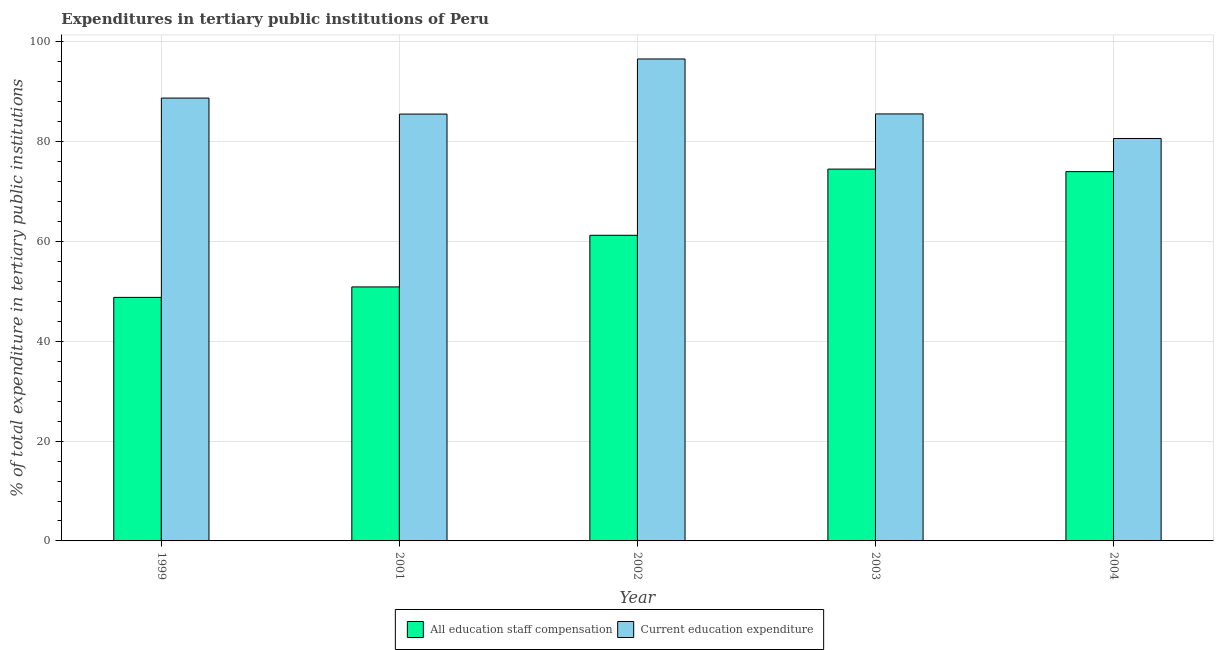How many different coloured bars are there?
Your answer should be compact. 2. Are the number of bars on each tick of the X-axis equal?
Offer a terse response. Yes. How many bars are there on the 1st tick from the left?
Your answer should be very brief. 2. What is the expenditure in education in 2001?
Offer a very short reply. 85.55. Across all years, what is the maximum expenditure in education?
Ensure brevity in your answer.  96.6. Across all years, what is the minimum expenditure in education?
Provide a succinct answer. 80.66. In which year was the expenditure in staff compensation maximum?
Ensure brevity in your answer.  2003. In which year was the expenditure in staff compensation minimum?
Keep it short and to the point. 1999. What is the total expenditure in education in the graph?
Provide a succinct answer. 437.14. What is the difference between the expenditure in education in 1999 and that in 2001?
Make the answer very short. 3.21. What is the difference between the expenditure in staff compensation in 2003 and the expenditure in education in 2004?
Ensure brevity in your answer.  0.51. What is the average expenditure in staff compensation per year?
Make the answer very short. 61.9. What is the ratio of the expenditure in education in 1999 to that in 2001?
Give a very brief answer. 1.04. Is the expenditure in education in 2001 less than that in 2004?
Give a very brief answer. No. Is the difference between the expenditure in education in 1999 and 2002 greater than the difference between the expenditure in staff compensation in 1999 and 2002?
Keep it short and to the point. No. What is the difference between the highest and the second highest expenditure in education?
Keep it short and to the point. 7.84. What is the difference between the highest and the lowest expenditure in education?
Give a very brief answer. 15.93. In how many years, is the expenditure in staff compensation greater than the average expenditure in staff compensation taken over all years?
Offer a very short reply. 2. Is the sum of the expenditure in education in 1999 and 2001 greater than the maximum expenditure in staff compensation across all years?
Your response must be concise. Yes. What does the 2nd bar from the left in 2003 represents?
Give a very brief answer. Current education expenditure. What does the 2nd bar from the right in 2001 represents?
Your response must be concise. All education staff compensation. How many bars are there?
Ensure brevity in your answer.  10. Are the values on the major ticks of Y-axis written in scientific E-notation?
Provide a short and direct response. No. Does the graph contain grids?
Provide a succinct answer. Yes. How are the legend labels stacked?
Keep it short and to the point. Horizontal. What is the title of the graph?
Your answer should be very brief. Expenditures in tertiary public institutions of Peru. Does "Male population" appear as one of the legend labels in the graph?
Your answer should be compact. No. What is the label or title of the Y-axis?
Offer a terse response. % of total expenditure in tertiary public institutions. What is the % of total expenditure in tertiary public institutions of All education staff compensation in 1999?
Keep it short and to the point. 48.81. What is the % of total expenditure in tertiary public institutions of Current education expenditure in 1999?
Give a very brief answer. 88.76. What is the % of total expenditure in tertiary public institutions of All education staff compensation in 2001?
Provide a succinct answer. 50.91. What is the % of total expenditure in tertiary public institutions of Current education expenditure in 2001?
Your answer should be very brief. 85.55. What is the % of total expenditure in tertiary public institutions in All education staff compensation in 2002?
Offer a terse response. 61.26. What is the % of total expenditure in tertiary public institutions of Current education expenditure in 2002?
Offer a terse response. 96.6. What is the % of total expenditure in tertiary public institutions of All education staff compensation in 2003?
Make the answer very short. 74.52. What is the % of total expenditure in tertiary public institutions in Current education expenditure in 2003?
Offer a very short reply. 85.58. What is the % of total expenditure in tertiary public institutions of All education staff compensation in 2004?
Your answer should be very brief. 74.02. What is the % of total expenditure in tertiary public institutions of Current education expenditure in 2004?
Ensure brevity in your answer.  80.66. Across all years, what is the maximum % of total expenditure in tertiary public institutions in All education staff compensation?
Provide a short and direct response. 74.52. Across all years, what is the maximum % of total expenditure in tertiary public institutions of Current education expenditure?
Keep it short and to the point. 96.6. Across all years, what is the minimum % of total expenditure in tertiary public institutions of All education staff compensation?
Your answer should be very brief. 48.81. Across all years, what is the minimum % of total expenditure in tertiary public institutions in Current education expenditure?
Ensure brevity in your answer.  80.66. What is the total % of total expenditure in tertiary public institutions of All education staff compensation in the graph?
Give a very brief answer. 309.52. What is the total % of total expenditure in tertiary public institutions of Current education expenditure in the graph?
Your answer should be very brief. 437.14. What is the difference between the % of total expenditure in tertiary public institutions in All education staff compensation in 1999 and that in 2001?
Your answer should be compact. -2.1. What is the difference between the % of total expenditure in tertiary public institutions in Current education expenditure in 1999 and that in 2001?
Offer a very short reply. 3.21. What is the difference between the % of total expenditure in tertiary public institutions of All education staff compensation in 1999 and that in 2002?
Provide a short and direct response. -12.44. What is the difference between the % of total expenditure in tertiary public institutions of Current education expenditure in 1999 and that in 2002?
Your answer should be compact. -7.84. What is the difference between the % of total expenditure in tertiary public institutions of All education staff compensation in 1999 and that in 2003?
Offer a very short reply. -25.71. What is the difference between the % of total expenditure in tertiary public institutions of Current education expenditure in 1999 and that in 2003?
Your answer should be very brief. 3.18. What is the difference between the % of total expenditure in tertiary public institutions of All education staff compensation in 1999 and that in 2004?
Offer a very short reply. -25.2. What is the difference between the % of total expenditure in tertiary public institutions in Current education expenditure in 1999 and that in 2004?
Give a very brief answer. 8.09. What is the difference between the % of total expenditure in tertiary public institutions in All education staff compensation in 2001 and that in 2002?
Your answer should be compact. -10.34. What is the difference between the % of total expenditure in tertiary public institutions in Current education expenditure in 2001 and that in 2002?
Offer a very short reply. -11.05. What is the difference between the % of total expenditure in tertiary public institutions of All education staff compensation in 2001 and that in 2003?
Provide a short and direct response. -23.61. What is the difference between the % of total expenditure in tertiary public institutions in Current education expenditure in 2001 and that in 2003?
Offer a very short reply. -0.03. What is the difference between the % of total expenditure in tertiary public institutions of All education staff compensation in 2001 and that in 2004?
Provide a short and direct response. -23.1. What is the difference between the % of total expenditure in tertiary public institutions in Current education expenditure in 2001 and that in 2004?
Your answer should be compact. 4.89. What is the difference between the % of total expenditure in tertiary public institutions of All education staff compensation in 2002 and that in 2003?
Your answer should be compact. -13.27. What is the difference between the % of total expenditure in tertiary public institutions in Current education expenditure in 2002 and that in 2003?
Keep it short and to the point. 11.02. What is the difference between the % of total expenditure in tertiary public institutions of All education staff compensation in 2002 and that in 2004?
Ensure brevity in your answer.  -12.76. What is the difference between the % of total expenditure in tertiary public institutions of Current education expenditure in 2002 and that in 2004?
Keep it short and to the point. 15.93. What is the difference between the % of total expenditure in tertiary public institutions in All education staff compensation in 2003 and that in 2004?
Keep it short and to the point. 0.51. What is the difference between the % of total expenditure in tertiary public institutions in Current education expenditure in 2003 and that in 2004?
Provide a succinct answer. 4.92. What is the difference between the % of total expenditure in tertiary public institutions in All education staff compensation in 1999 and the % of total expenditure in tertiary public institutions in Current education expenditure in 2001?
Make the answer very short. -36.74. What is the difference between the % of total expenditure in tertiary public institutions in All education staff compensation in 1999 and the % of total expenditure in tertiary public institutions in Current education expenditure in 2002?
Keep it short and to the point. -47.78. What is the difference between the % of total expenditure in tertiary public institutions of All education staff compensation in 1999 and the % of total expenditure in tertiary public institutions of Current education expenditure in 2003?
Give a very brief answer. -36.77. What is the difference between the % of total expenditure in tertiary public institutions of All education staff compensation in 1999 and the % of total expenditure in tertiary public institutions of Current education expenditure in 2004?
Provide a short and direct response. -31.85. What is the difference between the % of total expenditure in tertiary public institutions of All education staff compensation in 2001 and the % of total expenditure in tertiary public institutions of Current education expenditure in 2002?
Provide a short and direct response. -45.68. What is the difference between the % of total expenditure in tertiary public institutions in All education staff compensation in 2001 and the % of total expenditure in tertiary public institutions in Current education expenditure in 2003?
Offer a very short reply. -34.67. What is the difference between the % of total expenditure in tertiary public institutions of All education staff compensation in 2001 and the % of total expenditure in tertiary public institutions of Current education expenditure in 2004?
Make the answer very short. -29.75. What is the difference between the % of total expenditure in tertiary public institutions in All education staff compensation in 2002 and the % of total expenditure in tertiary public institutions in Current education expenditure in 2003?
Your answer should be very brief. -24.32. What is the difference between the % of total expenditure in tertiary public institutions of All education staff compensation in 2002 and the % of total expenditure in tertiary public institutions of Current education expenditure in 2004?
Offer a very short reply. -19.41. What is the difference between the % of total expenditure in tertiary public institutions of All education staff compensation in 2003 and the % of total expenditure in tertiary public institutions of Current education expenditure in 2004?
Keep it short and to the point. -6.14. What is the average % of total expenditure in tertiary public institutions of All education staff compensation per year?
Your response must be concise. 61.9. What is the average % of total expenditure in tertiary public institutions in Current education expenditure per year?
Offer a very short reply. 87.43. In the year 1999, what is the difference between the % of total expenditure in tertiary public institutions of All education staff compensation and % of total expenditure in tertiary public institutions of Current education expenditure?
Offer a very short reply. -39.94. In the year 2001, what is the difference between the % of total expenditure in tertiary public institutions in All education staff compensation and % of total expenditure in tertiary public institutions in Current education expenditure?
Ensure brevity in your answer.  -34.64. In the year 2002, what is the difference between the % of total expenditure in tertiary public institutions in All education staff compensation and % of total expenditure in tertiary public institutions in Current education expenditure?
Provide a succinct answer. -35.34. In the year 2003, what is the difference between the % of total expenditure in tertiary public institutions of All education staff compensation and % of total expenditure in tertiary public institutions of Current education expenditure?
Provide a succinct answer. -11.06. In the year 2004, what is the difference between the % of total expenditure in tertiary public institutions in All education staff compensation and % of total expenditure in tertiary public institutions in Current education expenditure?
Your answer should be compact. -6.65. What is the ratio of the % of total expenditure in tertiary public institutions in All education staff compensation in 1999 to that in 2001?
Ensure brevity in your answer.  0.96. What is the ratio of the % of total expenditure in tertiary public institutions in Current education expenditure in 1999 to that in 2001?
Your answer should be very brief. 1.04. What is the ratio of the % of total expenditure in tertiary public institutions in All education staff compensation in 1999 to that in 2002?
Give a very brief answer. 0.8. What is the ratio of the % of total expenditure in tertiary public institutions of Current education expenditure in 1999 to that in 2002?
Your answer should be compact. 0.92. What is the ratio of the % of total expenditure in tertiary public institutions of All education staff compensation in 1999 to that in 2003?
Ensure brevity in your answer.  0.66. What is the ratio of the % of total expenditure in tertiary public institutions of Current education expenditure in 1999 to that in 2003?
Offer a very short reply. 1.04. What is the ratio of the % of total expenditure in tertiary public institutions of All education staff compensation in 1999 to that in 2004?
Your response must be concise. 0.66. What is the ratio of the % of total expenditure in tertiary public institutions of Current education expenditure in 1999 to that in 2004?
Offer a very short reply. 1.1. What is the ratio of the % of total expenditure in tertiary public institutions in All education staff compensation in 2001 to that in 2002?
Give a very brief answer. 0.83. What is the ratio of the % of total expenditure in tertiary public institutions of Current education expenditure in 2001 to that in 2002?
Make the answer very short. 0.89. What is the ratio of the % of total expenditure in tertiary public institutions in All education staff compensation in 2001 to that in 2003?
Make the answer very short. 0.68. What is the ratio of the % of total expenditure in tertiary public institutions of All education staff compensation in 2001 to that in 2004?
Your answer should be very brief. 0.69. What is the ratio of the % of total expenditure in tertiary public institutions of Current education expenditure in 2001 to that in 2004?
Your answer should be compact. 1.06. What is the ratio of the % of total expenditure in tertiary public institutions in All education staff compensation in 2002 to that in 2003?
Your answer should be compact. 0.82. What is the ratio of the % of total expenditure in tertiary public institutions of Current education expenditure in 2002 to that in 2003?
Your answer should be compact. 1.13. What is the ratio of the % of total expenditure in tertiary public institutions of All education staff compensation in 2002 to that in 2004?
Offer a very short reply. 0.83. What is the ratio of the % of total expenditure in tertiary public institutions in Current education expenditure in 2002 to that in 2004?
Your response must be concise. 1.2. What is the ratio of the % of total expenditure in tertiary public institutions of Current education expenditure in 2003 to that in 2004?
Offer a terse response. 1.06. What is the difference between the highest and the second highest % of total expenditure in tertiary public institutions in All education staff compensation?
Offer a very short reply. 0.51. What is the difference between the highest and the second highest % of total expenditure in tertiary public institutions of Current education expenditure?
Offer a very short reply. 7.84. What is the difference between the highest and the lowest % of total expenditure in tertiary public institutions in All education staff compensation?
Provide a short and direct response. 25.71. What is the difference between the highest and the lowest % of total expenditure in tertiary public institutions in Current education expenditure?
Ensure brevity in your answer.  15.93. 